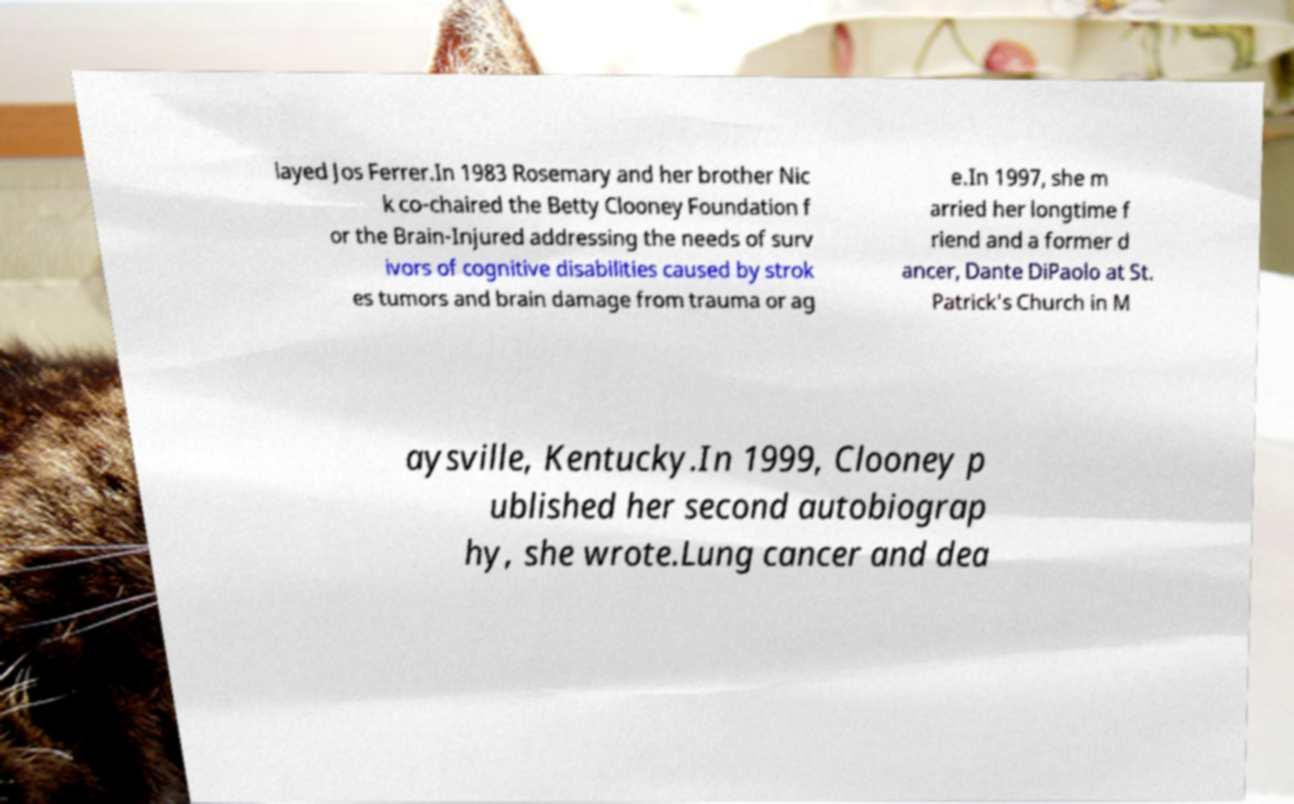Could you assist in decoding the text presented in this image and type it out clearly? layed Jos Ferrer.In 1983 Rosemary and her brother Nic k co-chaired the Betty Clooney Foundation f or the Brain-Injured addressing the needs of surv ivors of cognitive disabilities caused by strok es tumors and brain damage from trauma or ag e.In 1997, she m arried her longtime f riend and a former d ancer, Dante DiPaolo at St. Patrick's Church in M aysville, Kentucky.In 1999, Clooney p ublished her second autobiograp hy, she wrote.Lung cancer and dea 